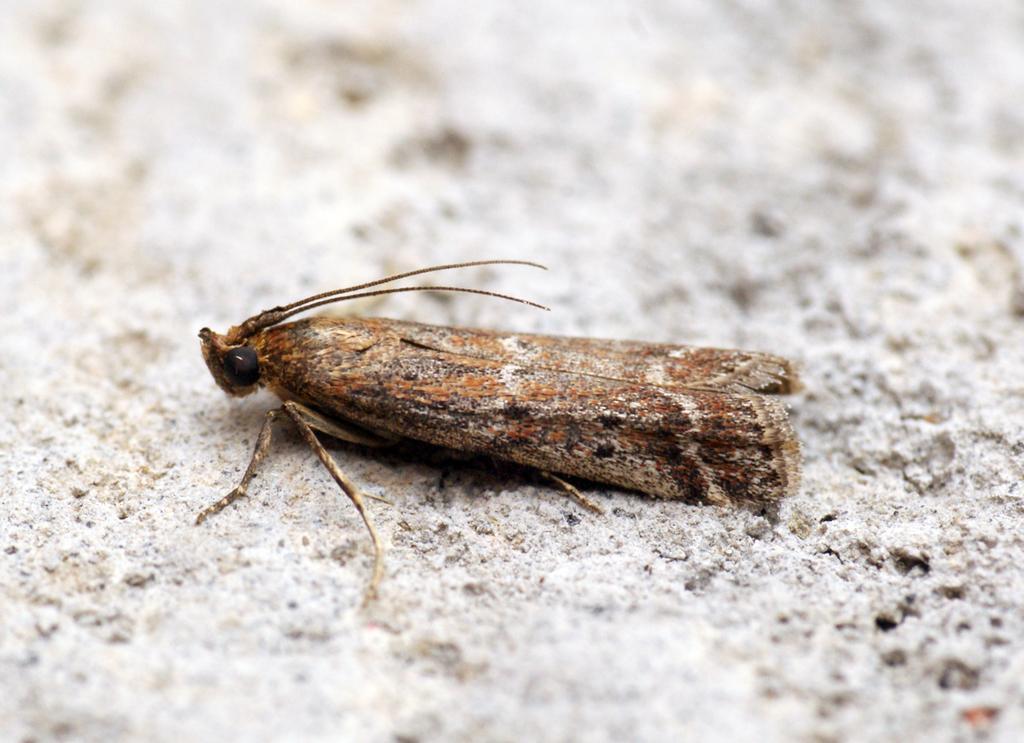In one or two sentences, can you explain what this image depicts? In this image there is an insect, in the background it is blurred. 